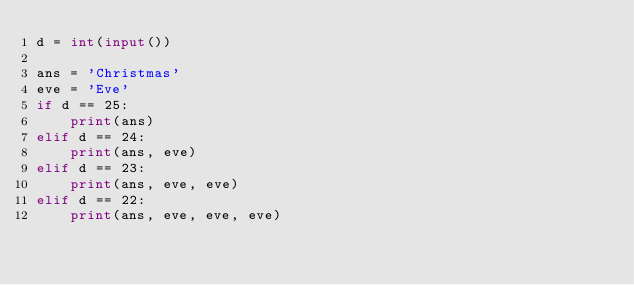<code> <loc_0><loc_0><loc_500><loc_500><_Python_>d = int(input())

ans = 'Christmas'
eve = 'Eve'
if d == 25:
    print(ans)
elif d == 24:
    print(ans, eve)
elif d == 23:
    print(ans, eve, eve)
elif d == 22:
    print(ans, eve, eve, eve)
</code> 